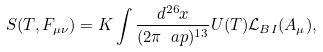<formula> <loc_0><loc_0><loc_500><loc_500>S ( T , F _ { \mu \nu } ) = K \int \frac { d ^ { 2 6 } x } { ( 2 \pi \ a p ) ^ { 1 3 } } U ( T ) \mathcal { L } _ { B I } ( A _ { \mu } ) ,</formula> 